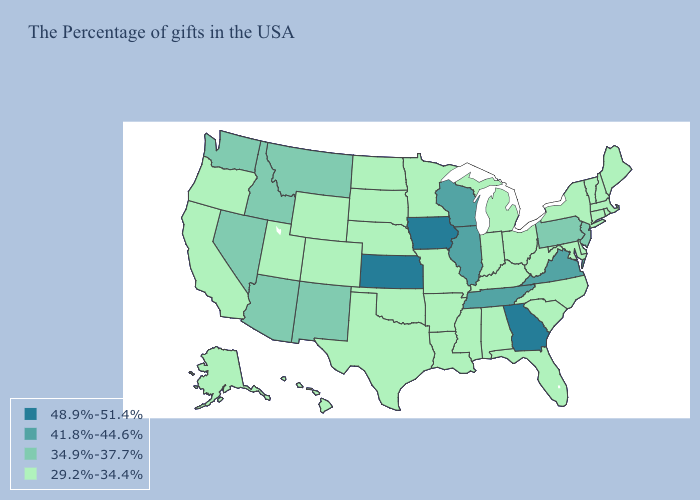Does the first symbol in the legend represent the smallest category?
Concise answer only. No. Does Texas have a lower value than Michigan?
Concise answer only. No. What is the highest value in states that border North Carolina?
Keep it brief. 48.9%-51.4%. What is the highest value in the West ?
Concise answer only. 34.9%-37.7%. Name the states that have a value in the range 34.9%-37.7%?
Give a very brief answer. New Jersey, Pennsylvania, New Mexico, Montana, Arizona, Idaho, Nevada, Washington. What is the value of Idaho?
Quick response, please. 34.9%-37.7%. What is the value of Arkansas?
Concise answer only. 29.2%-34.4%. What is the value of Utah?
Answer briefly. 29.2%-34.4%. Name the states that have a value in the range 41.8%-44.6%?
Short answer required. Virginia, Tennessee, Wisconsin, Illinois. Name the states that have a value in the range 48.9%-51.4%?
Concise answer only. Georgia, Iowa, Kansas. Among the states that border North Carolina , does Georgia have the lowest value?
Quick response, please. No. What is the lowest value in states that border Minnesota?
Keep it brief. 29.2%-34.4%. Among the states that border Idaho , which have the highest value?
Short answer required. Montana, Nevada, Washington. What is the value of New York?
Concise answer only. 29.2%-34.4%. Which states have the lowest value in the West?
Concise answer only. Wyoming, Colorado, Utah, California, Oregon, Alaska, Hawaii. 